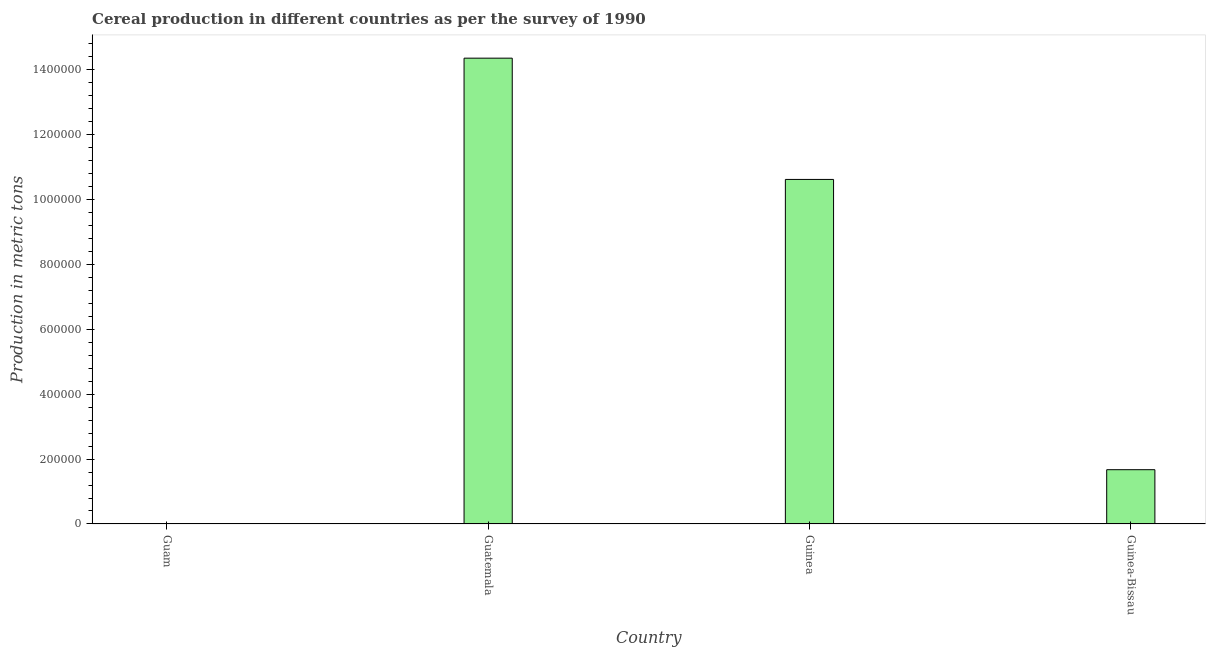What is the title of the graph?
Your response must be concise. Cereal production in different countries as per the survey of 1990. What is the label or title of the X-axis?
Give a very brief answer. Country. What is the label or title of the Y-axis?
Provide a succinct answer. Production in metric tons. What is the cereal production in Guinea-Bissau?
Give a very brief answer. 1.67e+05. Across all countries, what is the maximum cereal production?
Ensure brevity in your answer.  1.44e+06. Across all countries, what is the minimum cereal production?
Offer a terse response. 21. In which country was the cereal production maximum?
Provide a succinct answer. Guatemala. In which country was the cereal production minimum?
Offer a very short reply. Guam. What is the sum of the cereal production?
Give a very brief answer. 2.66e+06. What is the difference between the cereal production in Guatemala and Guinea?
Offer a terse response. 3.74e+05. What is the average cereal production per country?
Your answer should be compact. 6.66e+05. What is the median cereal production?
Your answer should be very brief. 6.14e+05. In how many countries, is the cereal production greater than 480000 metric tons?
Provide a succinct answer. 2. What is the ratio of the cereal production in Guatemala to that in Guinea-Bissau?
Make the answer very short. 8.58. Is the difference between the cereal production in Guatemala and Guinea-Bissau greater than the difference between any two countries?
Your answer should be very brief. No. What is the difference between the highest and the second highest cereal production?
Your answer should be very brief. 3.74e+05. What is the difference between the highest and the lowest cereal production?
Provide a succinct answer. 1.44e+06. In how many countries, is the cereal production greater than the average cereal production taken over all countries?
Your answer should be compact. 2. How many bars are there?
Offer a terse response. 4. What is the difference between two consecutive major ticks on the Y-axis?
Offer a very short reply. 2.00e+05. Are the values on the major ticks of Y-axis written in scientific E-notation?
Provide a short and direct response. No. What is the Production in metric tons in Guam?
Keep it short and to the point. 21. What is the Production in metric tons in Guatemala?
Your response must be concise. 1.44e+06. What is the Production in metric tons in Guinea?
Provide a short and direct response. 1.06e+06. What is the Production in metric tons of Guinea-Bissau?
Offer a terse response. 1.67e+05. What is the difference between the Production in metric tons in Guam and Guatemala?
Your response must be concise. -1.44e+06. What is the difference between the Production in metric tons in Guam and Guinea?
Provide a succinct answer. -1.06e+06. What is the difference between the Production in metric tons in Guam and Guinea-Bissau?
Offer a terse response. -1.67e+05. What is the difference between the Production in metric tons in Guatemala and Guinea?
Offer a terse response. 3.74e+05. What is the difference between the Production in metric tons in Guatemala and Guinea-Bissau?
Offer a very short reply. 1.27e+06. What is the difference between the Production in metric tons in Guinea and Guinea-Bissau?
Provide a succinct answer. 8.94e+05. What is the ratio of the Production in metric tons in Guam to that in Guinea-Bissau?
Your answer should be very brief. 0. What is the ratio of the Production in metric tons in Guatemala to that in Guinea?
Make the answer very short. 1.35. What is the ratio of the Production in metric tons in Guatemala to that in Guinea-Bissau?
Offer a very short reply. 8.58. What is the ratio of the Production in metric tons in Guinea to that in Guinea-Bissau?
Offer a very short reply. 6.35. 